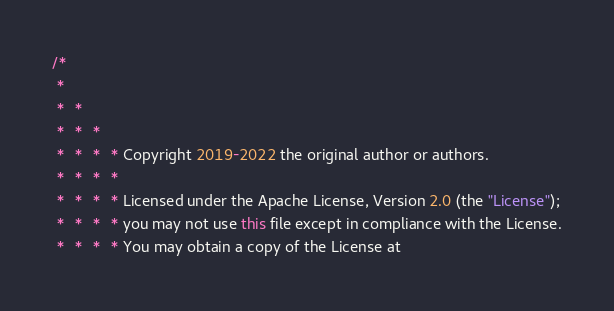<code> <loc_0><loc_0><loc_500><loc_500><_Java_>/*
 *
 *  *
 *  *  *
 *  *  *  * Copyright 2019-2022 the original author or authors.
 *  *  *  *
 *  *  *  * Licensed under the Apache License, Version 2.0 (the "License");
 *  *  *  * you may not use this file except in compliance with the License.
 *  *  *  * You may obtain a copy of the License at</code> 